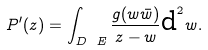<formula> <loc_0><loc_0><loc_500><loc_500>P ^ { \prime } ( z ) = \int _ { D \ E } \frac { g ( w \bar { w } ) } { z - w } \text {d} ^ { 2 } w .</formula> 